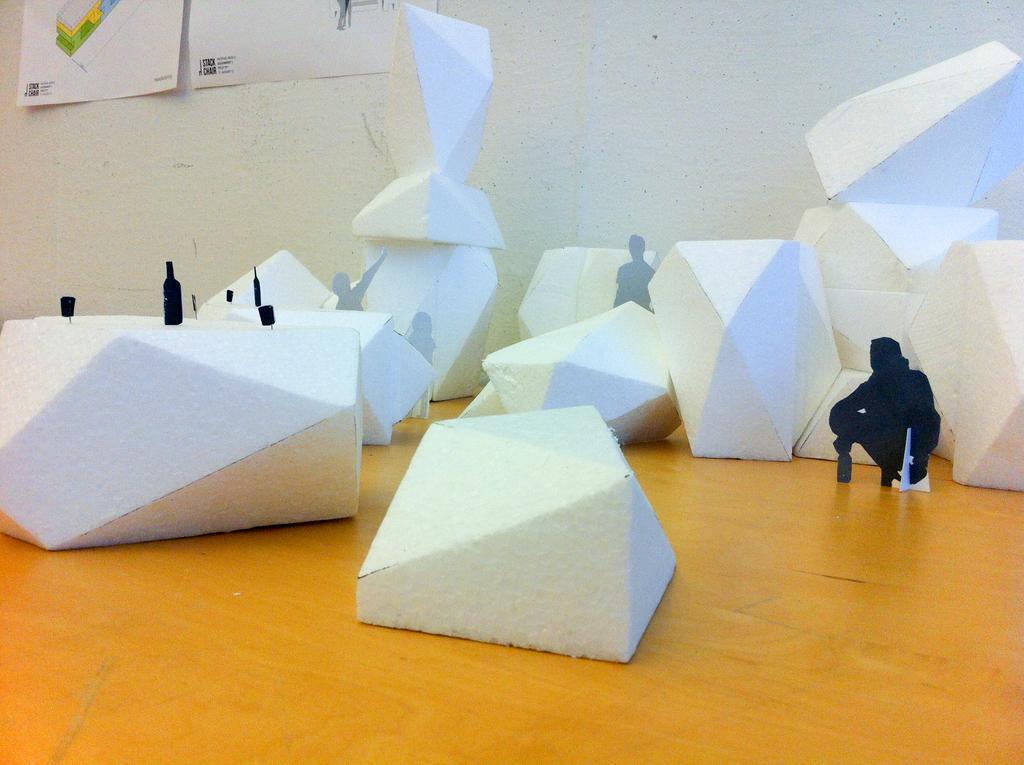Can you describe this image briefly? In this image we can see these white color objects are kept on the wooden surface. In the background, we can see two posts are attached to the wall. 